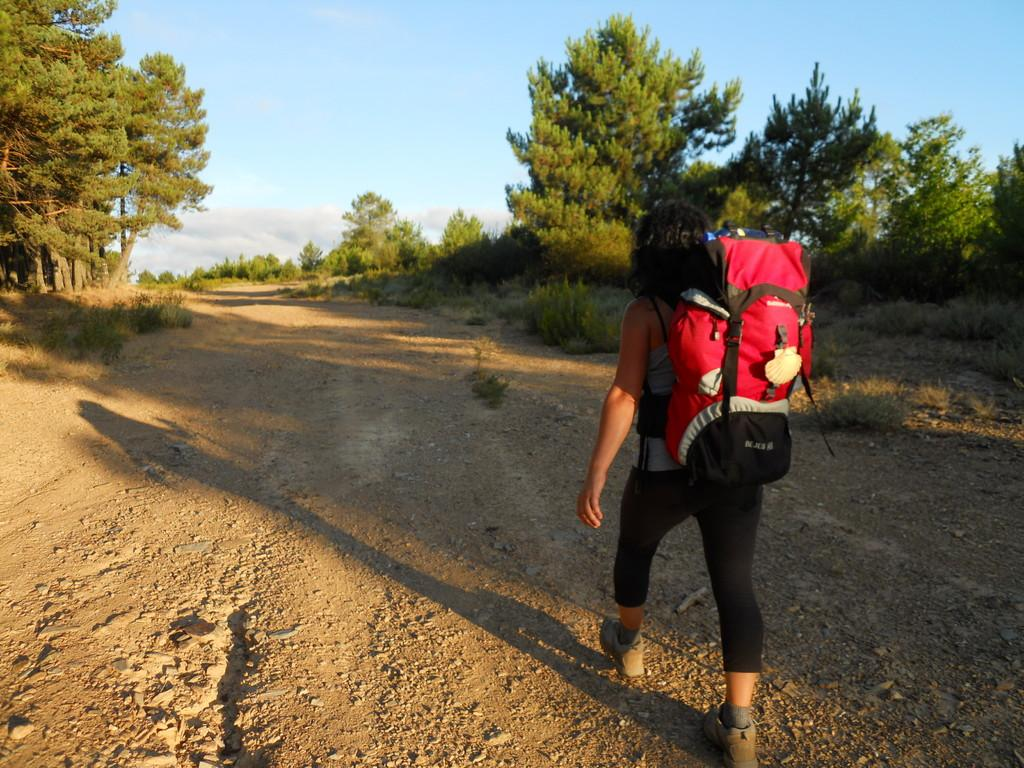What is the person in the image doing? The person in the image is walking. What is the person carrying while walking? The person is carrying a bag. What can be seen in the image besides the person? There is a pathway, trees and plants, and the sky visible in the image. What color is the blood on the person's shirt in the image? There is no blood present on the person's shirt in the image. Is there a chicken walking alongside the person in the image? There is no chicken present in the image. 